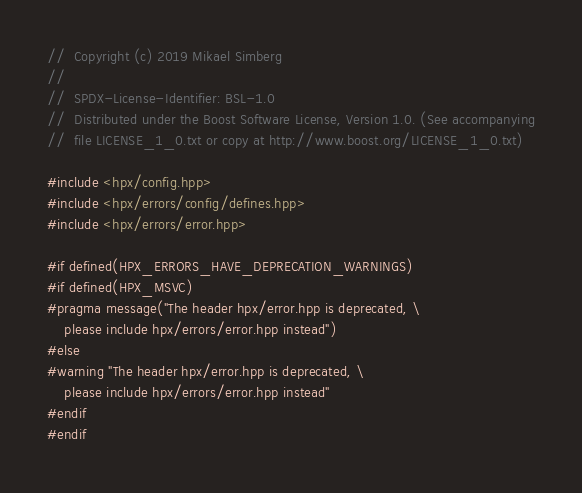<code> <loc_0><loc_0><loc_500><loc_500><_C++_>//  Copyright (c) 2019 Mikael Simberg
//
//  SPDX-License-Identifier: BSL-1.0
//  Distributed under the Boost Software License, Version 1.0. (See accompanying
//  file LICENSE_1_0.txt or copy at http://www.boost.org/LICENSE_1_0.txt)

#include <hpx/config.hpp>
#include <hpx/errors/config/defines.hpp>
#include <hpx/errors/error.hpp>

#if defined(HPX_ERRORS_HAVE_DEPRECATION_WARNINGS)
#if defined(HPX_MSVC)
#pragma message("The header hpx/error.hpp is deprecated, \
    please include hpx/errors/error.hpp instead")
#else
#warning "The header hpx/error.hpp is deprecated, \
    please include hpx/errors/error.hpp instead"
#endif
#endif
</code> 